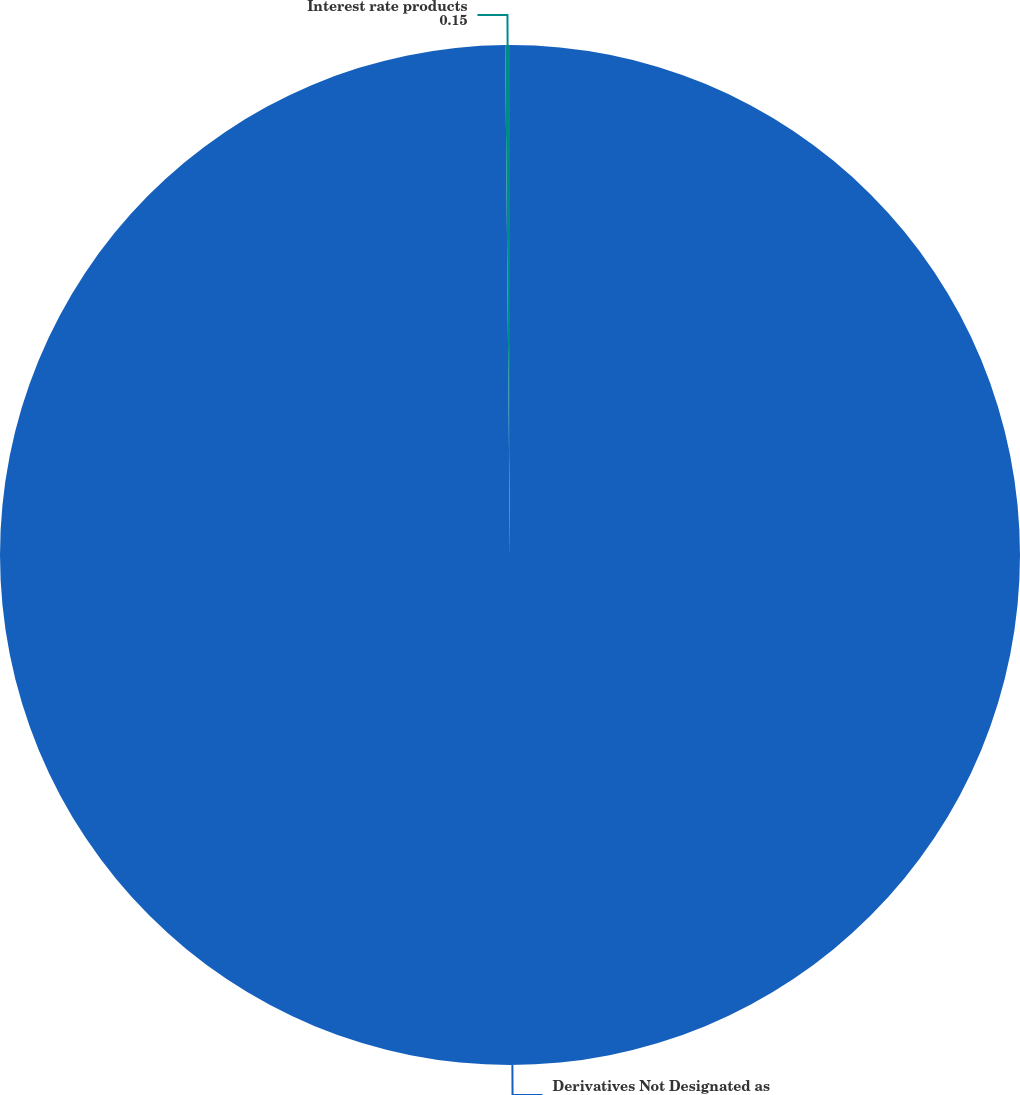Convert chart to OTSL. <chart><loc_0><loc_0><loc_500><loc_500><pie_chart><fcel>Derivatives Not Designated as<fcel>Interest rate products<nl><fcel>99.85%<fcel>0.15%<nl></chart> 